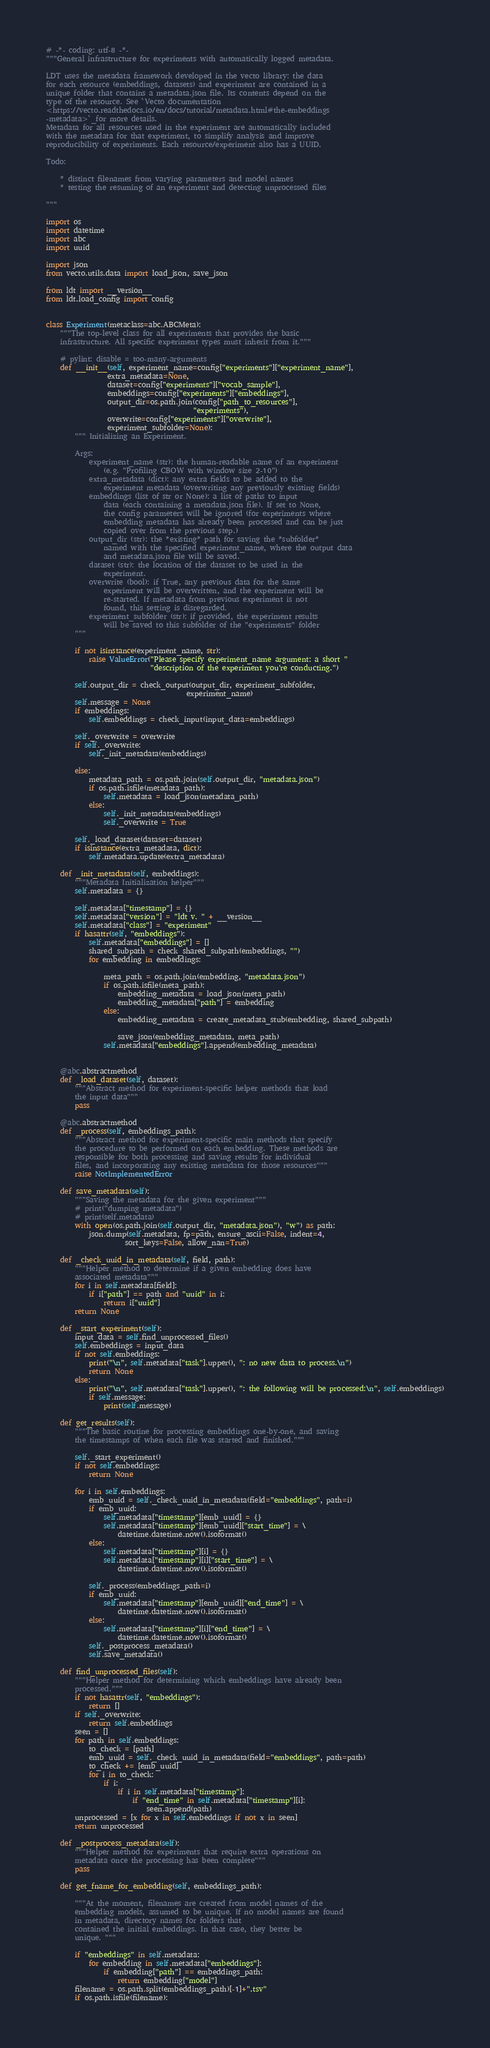<code> <loc_0><loc_0><loc_500><loc_500><_Python_># -*- coding: utf-8 -*-
"""General infrastructure for experiments with automatically logged metadata.

LDT uses the metadata framework developed in the vecto library: the data
for each resource (embeddings, datasets) and experiment are contained in a
unique folder that contains a metadata.json file. Its contents depend on the
type of the resource. See `Vecto documentation
<https://vecto.readthedocs.io/en/docs/tutorial/metadata.html#the-embeddings
-metadata>`_for more details.
Metadata for all resources used in the experiment are automatically included
with the metadata for that experiment, to simplify analysis and improve
reproducibility of experiments. Each resource/experiment also has a UUID.

Todo:

    * distinct filenames from varying parameters and model names
    * testing the resuming of an experiment and detecting unprocessed files

"""

import os
import datetime
import abc
import uuid

import json
from vecto.utils.data import load_json, save_json

from ldt import __version__
from ldt.load_config import config


class Experiment(metaclass=abc.ABCMeta):
    """The top-level class for all experiments that provides the basic
    infrastructure. All specific experiment types must inherit from it."""

    # pylint: disable = too-many-arguments
    def __init__(self, experiment_name=config["experiments"]["experiment_name"],
                 extra_metadata=None,
                 dataset=config["experiments"]["vocab_sample"],
                 embeddings=config["experiments"]["embeddings"],
                 output_dir=os.path.join(config["path_to_resources"],
                                         "experiments"),
                 overwrite=config["experiments"]["overwrite"],
                 experiment_subfolder=None):
        """ Initializing an Experiment.

        Args:
            experiment_name (str): the human-readable name of an experiment
                (e.g. "Profiling CBOW with window size 2-10")
            extra_metadata (dict): any extra fields to be added to the
                experiment metadata (overwriting any previously existing fields)
            embeddings (list of str or None): a list of paths to input
                data (each containing a metadata.json file). If set to None,
                the config parameters will be ignored (for experiments where
                embedding metadata has already been processed and can be just
                copied over from the previous step.)
            output_dir (str): the *existing* path for saving the *subfolder*
                named with the specified experiment_name, where the output data
                and metadata.json file will be saved.
            dataset (str): the location of the dataset to be used in the
                experiment.
            overwrite (bool): if True, any previous data for the same
                experiment will be overwritten, and the experiment will be
                re-started. If metadata from previous experiment is not
                found, this setting is disregarded.
            experiment_subfolder (str): if provided, the experiment results
                will be saved to this subfolder of the "experiments" folder
        """

        if not isinstance(experiment_name, str):
            raise ValueError("Please specify experiment_name argument: a short "
                             "description of the experiment you're conducting.")

        self.output_dir = check_output(output_dir, experiment_subfolder,
                                       experiment_name)
        self.message = None
        if embeddings:
            self.embeddings = check_input(input_data=embeddings)

        self._overwrite = overwrite
        if self._overwrite:
            self._init_metadata(embeddings)

        else:
            metadata_path = os.path.join(self.output_dir, "metadata.json")
            if os.path.isfile(metadata_path):
                self.metadata = load_json(metadata_path)
            else:
                self._init_metadata(embeddings)
                self._overwrite = True

        self._load_dataset(dataset=dataset)
        if isinstance(extra_metadata, dict):
            self.metadata.update(extra_metadata)

    def _init_metadata(self, embeddings):
        """Metadata Initialization helper"""
        self.metadata = {}

        self.metadata["timestamp"] = {}
        self.metadata["version"] = "ldt v. " + __version__
        self.metadata["class"] = "experiment"
        if hasattr(self, "embeddings"):
            self.metadata["embeddings"] = []
            shared_subpath = check_shared_subpath(embeddings, "")
            for embedding in embeddings:

                meta_path = os.path.join(embedding, "metadata.json")
                if os.path.isfile(meta_path):
                    embedding_metadata = load_json(meta_path)
                    embedding_metadata["path"] = embedding
                else:
                    embedding_metadata = create_metadata_stub(embedding, shared_subpath)

                    save_json(embedding_metadata, meta_path)
                self.metadata["embeddings"].append(embedding_metadata)


    @abc.abstractmethod
    def _load_dataset(self, dataset):
        """Abstract method for experiment-specific helper methods that load
        the input data"""
        pass

    @abc.abstractmethod
    def _process(self, embeddings_path):
        """Abstract method for experiment-specific main methods that specify
        the procedure to be performed on each embedding. These methods are
        responsible for both processing and saving results for individual
        files, and incorporating any existing metadata for those resources"""
        raise NotImplementedError

    def save_metadata(self):
        """Saving the metadata for the given experiment"""
        # print("dumping metadata")
        # print(self.metadata)
        with open(os.path.join(self.output_dir, "metadata.json"), "w") as path:
            json.dump(self.metadata, fp=path, ensure_ascii=False, indent=4,
                      sort_keys=False, allow_nan=True)

    def _check_uuid_in_metadata(self, field, path):
        """Helper method to determine if a given embedding does have
        associated metadata"""
        for i in self.metadata[field]:
            if i["path"] == path and "uuid" in i:
                return i["uuid"]
        return None

    def _start_experiment(self):
        input_data = self.find_unprocessed_files()
        self.embeddings = input_data
        if not self.embeddings:
            print("\n", self.metadata["task"].upper(), ": no new data to process.\n")
            return None
        else:
            print("\n", self.metadata["task"].upper(), ": the following will be processed:\n", self.embeddings)
            if self.message:
                print(self.message)

    def get_results(self):
        """The basic routine for processing embeddings one-by-one, and saving
        the timestamps of when each file was started and finished."""

        self._start_experiment()
        if not self.embeddings:
            return None

        for i in self.embeddings:
            emb_uuid = self._check_uuid_in_metadata(field="embeddings", path=i)
            if emb_uuid:
                self.metadata["timestamp"][emb_uuid] = {}
                self.metadata["timestamp"][emb_uuid]["start_time"] = \
                    datetime.datetime.now().isoformat()
            else:
                self.metadata["timestamp"][i] = {}
                self.metadata["timestamp"][i]["start_time"] = \
                    datetime.datetime.now().isoformat()

            self._process(embeddings_path=i)
            if emb_uuid:
                self.metadata["timestamp"][emb_uuid]["end_time"] = \
                    datetime.datetime.now().isoformat()
            else:
                self.metadata["timestamp"][i]["end_time"] = \
                    datetime.datetime.now().isoformat()
            self._postprocess_metadata()
            self.save_metadata()

    def find_unprocessed_files(self):
        """Helper method for determining which embeddings have already been
        processed."""
        if not hasattr(self, "embeddings"):
            return []
        if self._overwrite:
            return self.embeddings
        seen = []
        for path in self.embeddings:
            to_check = [path]
            emb_uuid = self._check_uuid_in_metadata(field="embeddings", path=path)
            to_check += [emb_uuid]
            for i in to_check:
                if i:
                    if i in self.metadata["timestamp"]:
                        if "end_time" in self.metadata["timestamp"][i]:
                            seen.append(path)
        unprocessed = [x for x in self.embeddings if not x in seen]
        return unprocessed

    def _postprocess_metadata(self):
        """Helper method for experiments that require extra operations on
        metadata once the processing has been complete"""
        pass

    def get_fname_for_embedding(self, embeddings_path):

        """At the moment, filenames are created from model names of the
        embedding models, assumed to be unique. If no model names are found
        in metadata, directory names for folders that
        contained the initial embeddings. In that case, they better be
        unique. """

        if "embeddings" in self.metadata:
            for embedding in self.metadata["embeddings"]:
                if embedding["path"] == embeddings_path:
                    return embedding["model"]
        filename = os.path.split(embeddings_path)[-1]+".tsv"
        if os.path.isfile(filename):</code> 